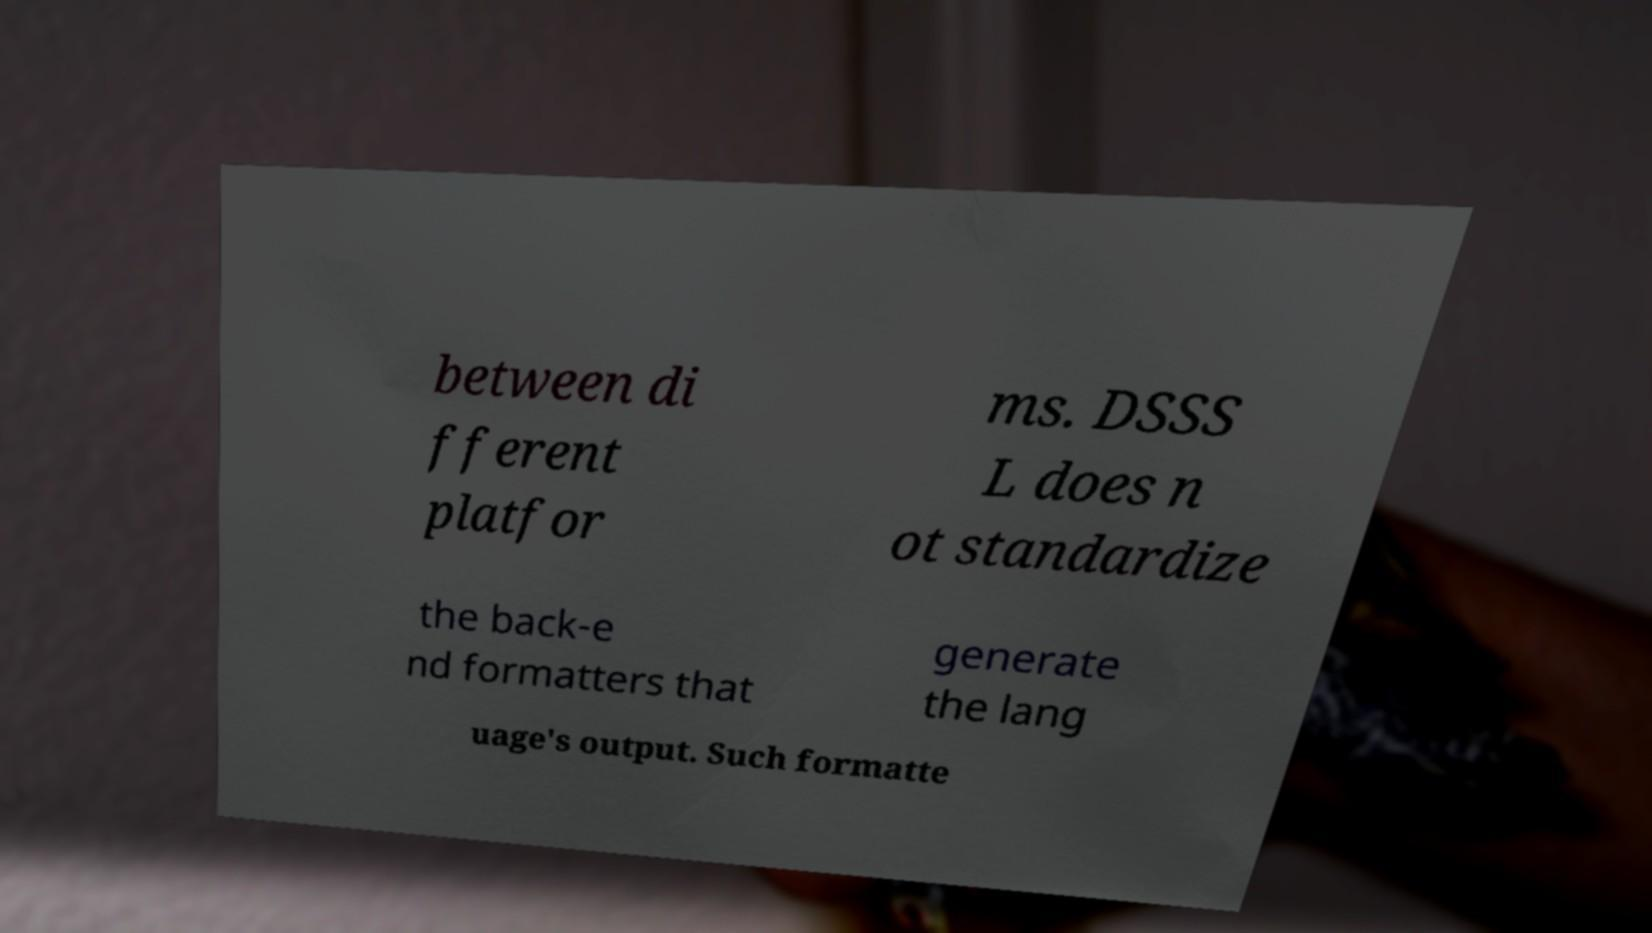Can you accurately transcribe the text from the provided image for me? between di fferent platfor ms. DSSS L does n ot standardize the back-e nd formatters that generate the lang uage's output. Such formatte 